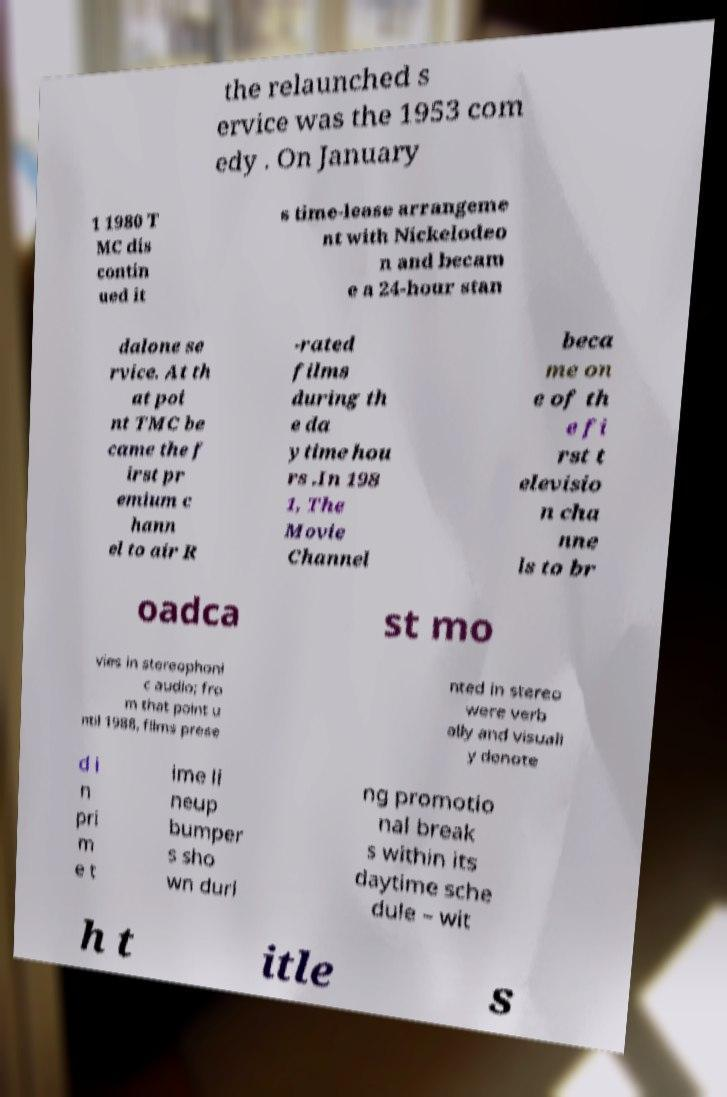There's text embedded in this image that I need extracted. Can you transcribe it verbatim? the relaunched s ervice was the 1953 com edy . On January 1 1980 T MC dis contin ued it s time-lease arrangeme nt with Nickelodeo n and becam e a 24-hour stan dalone se rvice. At th at poi nt TMC be came the f irst pr emium c hann el to air R -rated films during th e da ytime hou rs .In 198 1, The Movie Channel beca me on e of th e fi rst t elevisio n cha nne ls to br oadca st mo vies in stereophoni c audio; fro m that point u ntil 1988, films prese nted in stereo were verb ally and visuall y denote d i n pri m e t ime li neup bumper s sho wn duri ng promotio nal break s within its daytime sche dule – wit h t itle s 